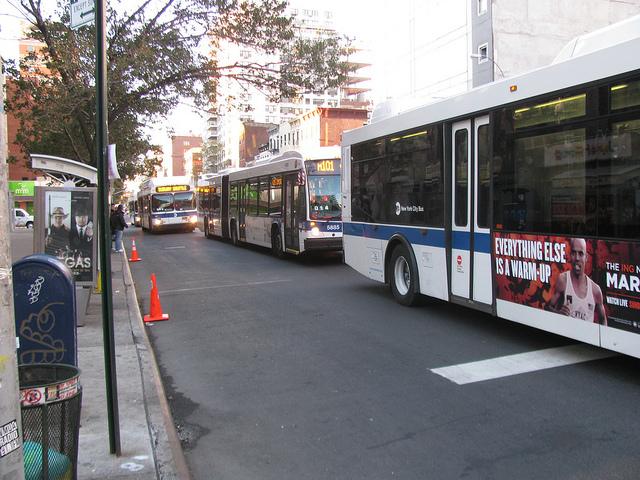How many buses are there?
Keep it brief. 3. Are they local buses?
Be succinct. Yes. Is there graffiti on the mailbox?
Quick response, please. Yes. 